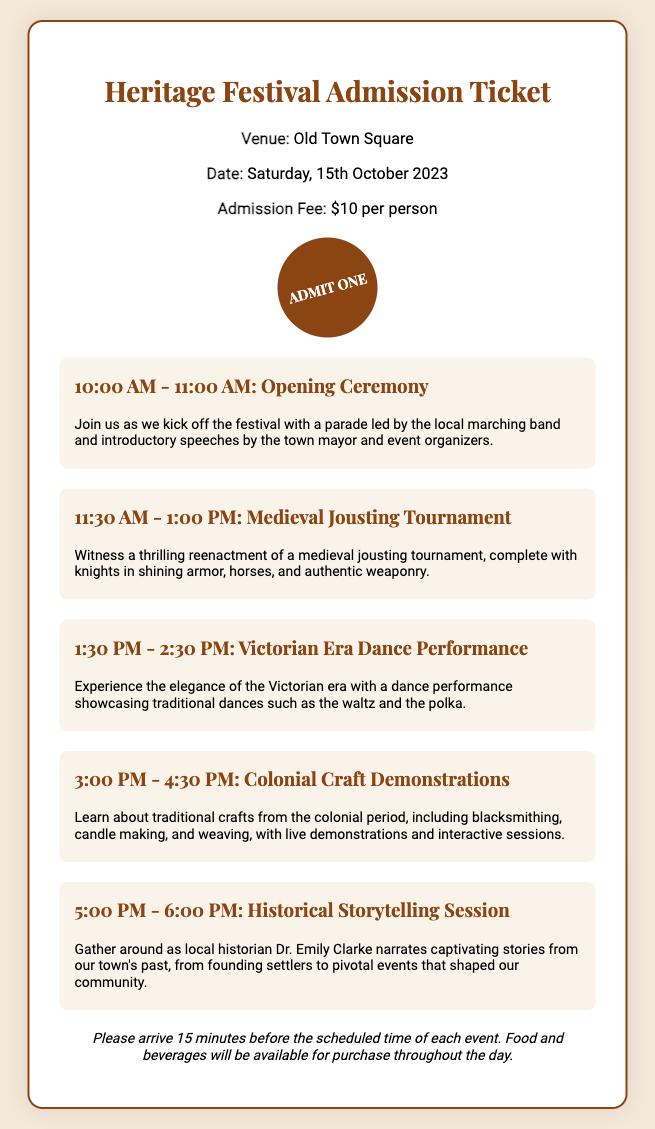What is the venue for the Heritage Festival? The venue is specified in the document under the venue section.
Answer: Old Town Square What is the date of the Heritage Festival? The date is mentioned clearly in the ticket information section.
Answer: Saturday, 15th October 2023 How much is the admission fee per person? The admission fee is indicated within the document's info section.
Answer: $10 Who is leading the parade during the opening ceremony? The opening ceremony description mentions the local group's involvement.
Answer: local marching band What time does the Victorian Era Dance Performance start? The scheduled time for the Victorian Era Dance Performance is provided in the events section.
Answer: 1:30 PM What is the duration of the Historical Storytelling Session? The duration can be calculated from the time provided for the storytelling session in the events section.
Answer: 1 hour Which historical figure narrates the Historical Storytelling Session? The document mentions the name of the local historian conducting the storytelling session.
Answer: Dr. Emily Clarke What type of event follows the Medieval Jousting Tournament? The event following the jousting tournament is listed in the order of events.
Answer: Victorian Era Dance Performance How many events are scheduled before the Colonial Craft Demonstrations? By counting the events listed up to that point, we can find the total.
Answer: 3 